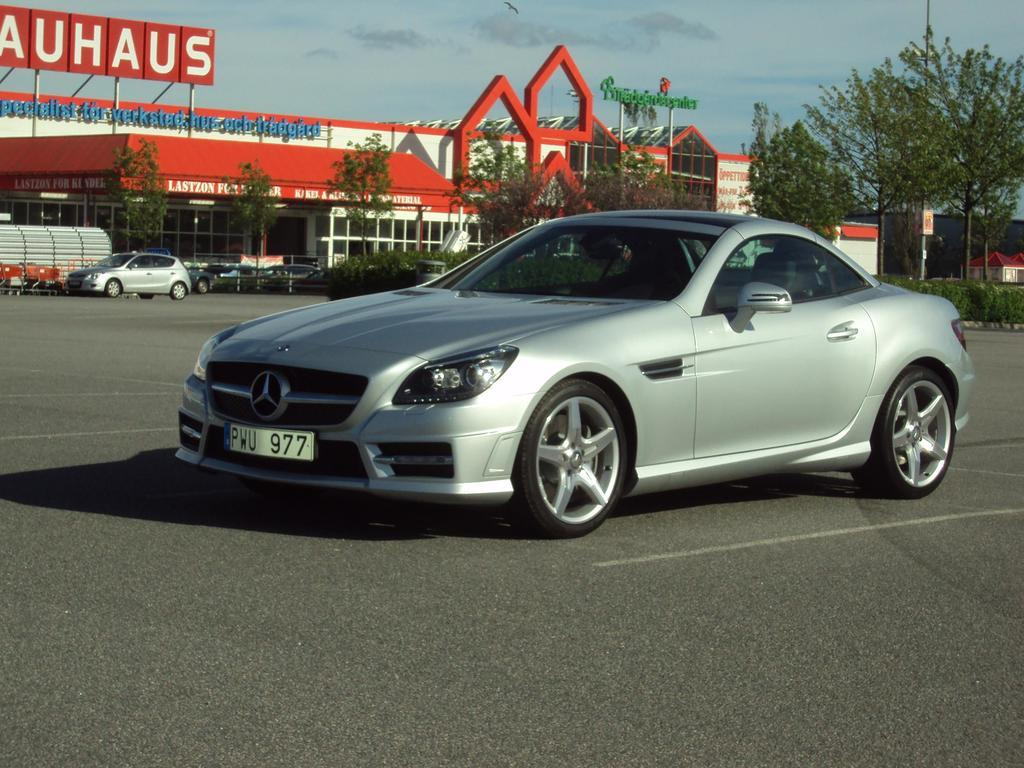<image>
Write a terse but informative summary of the picture. Gray car is parked in the parking lot near a sign that reads auhaus. 